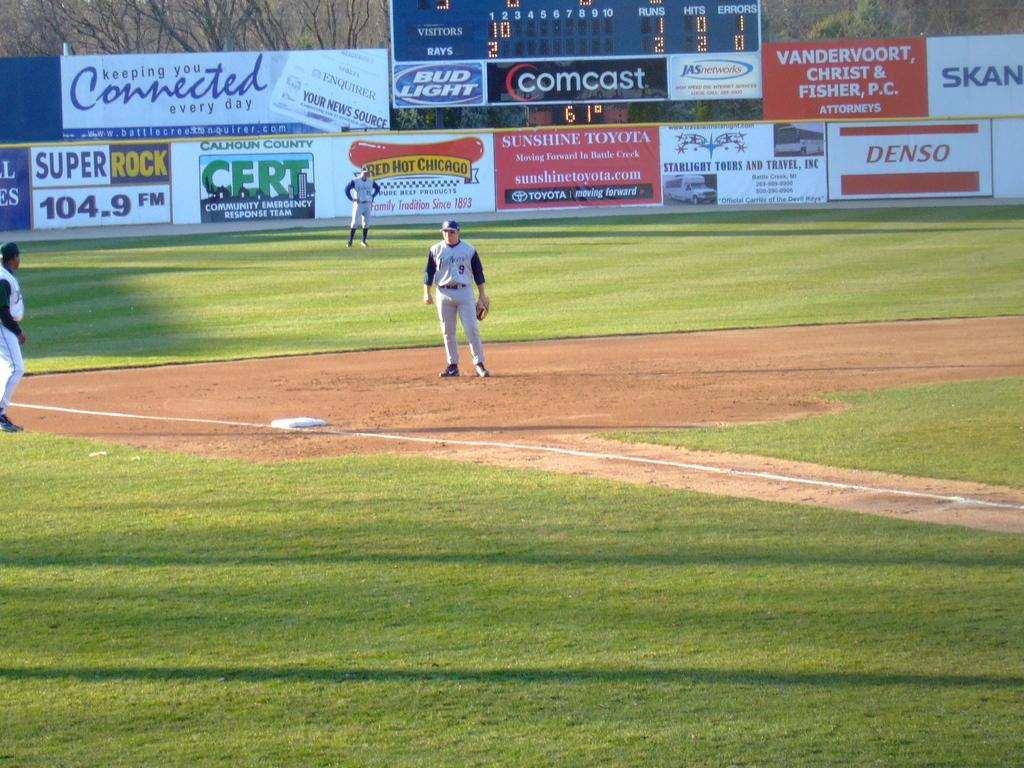<image>
Give a short and clear explanation of the subsequent image. A baseball game happens in front of a billboard that says Keeping you Connected every day. 